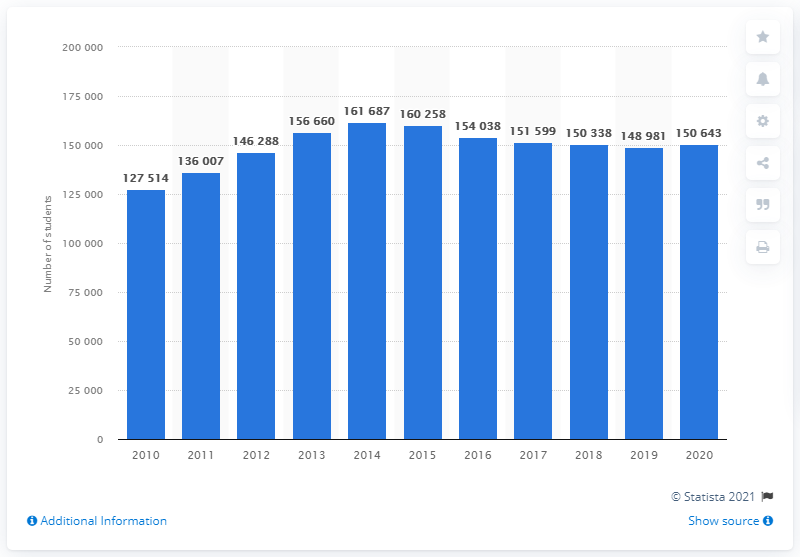Give some essential details in this illustration. In 2014, a total of 161,687 university students were registered in Denmark. In 2010, a total of 127,514 students were enrolled in Danish universities. In 2020, a total of 150,643 students were registered in Denmark. 